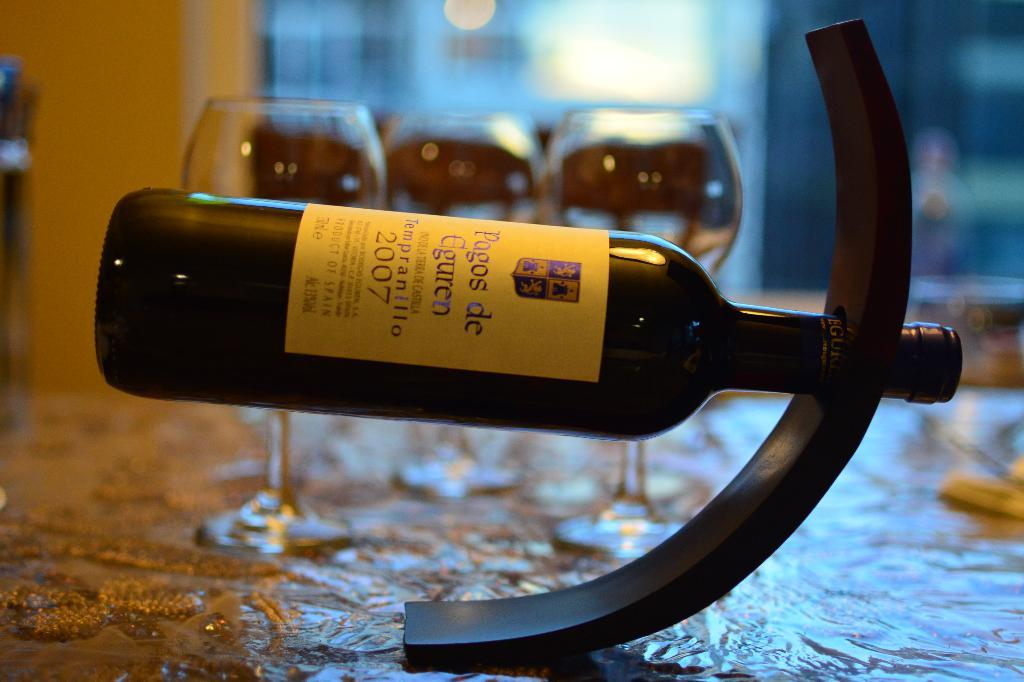<image>
Provide a brief description of the given image. A bottle of 2007 wine is displayed horizontally on a table. 